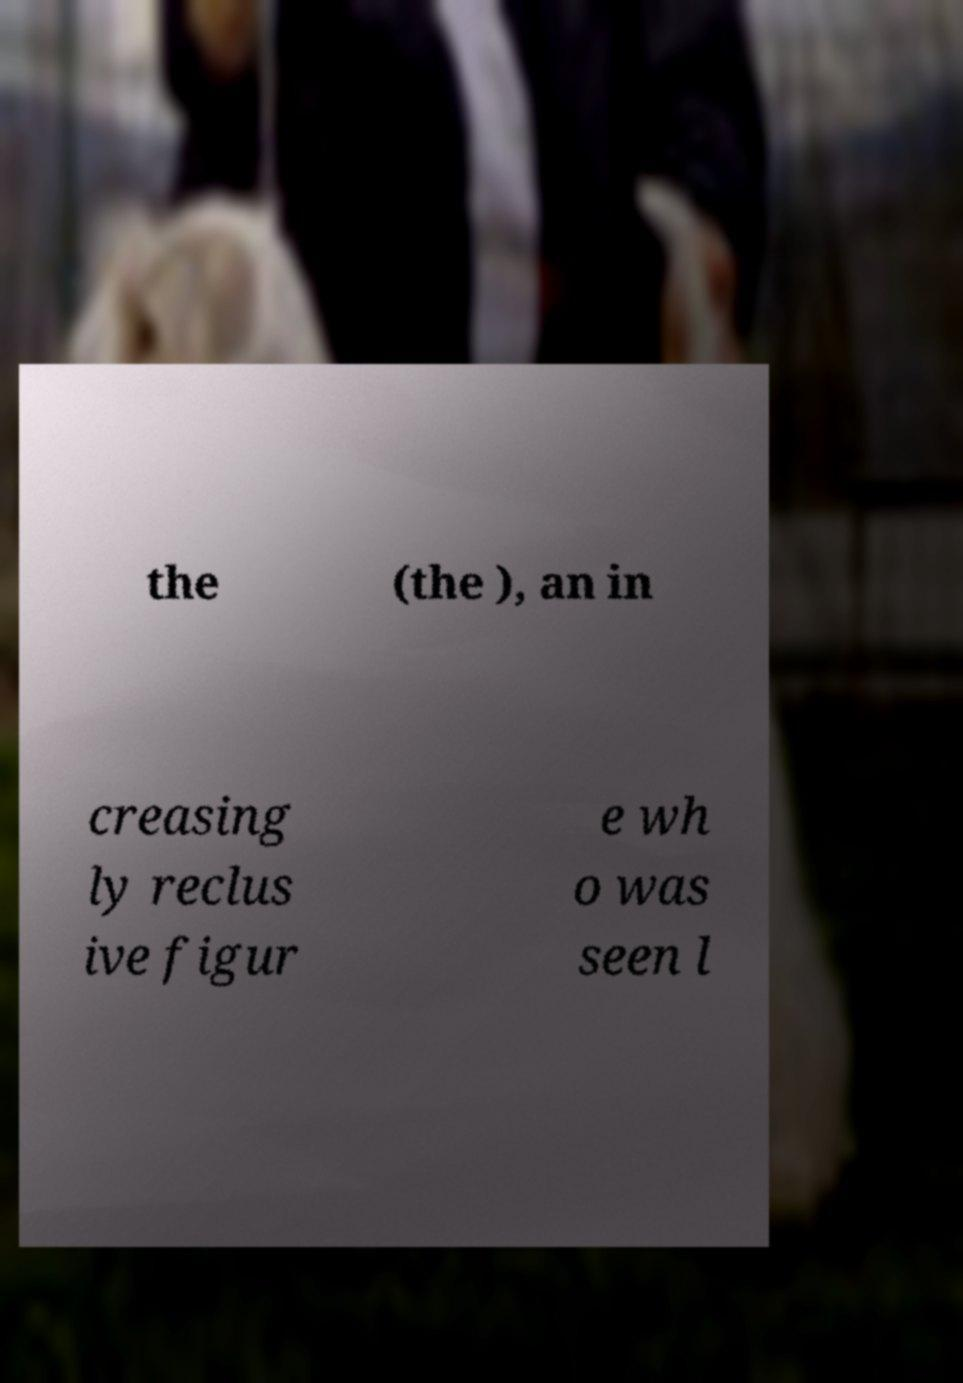I need the written content from this picture converted into text. Can you do that? the (the ), an in creasing ly reclus ive figur e wh o was seen l 